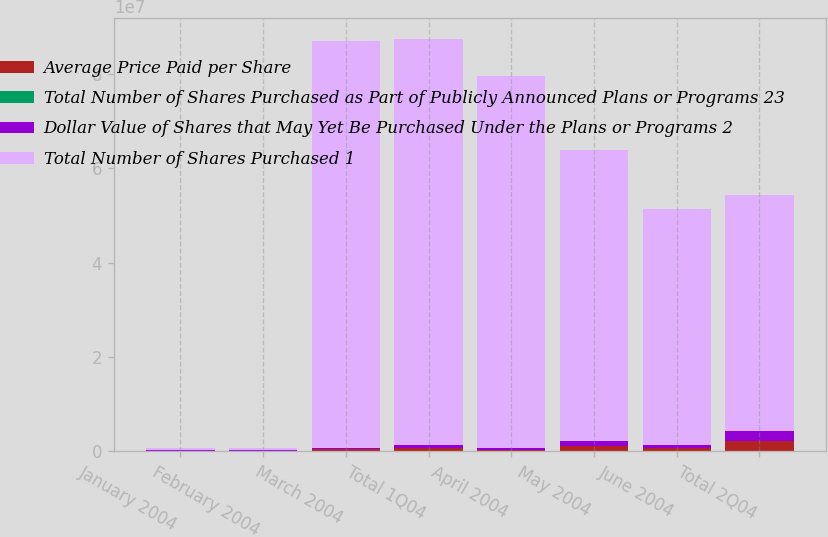Convert chart to OTSL. <chart><loc_0><loc_0><loc_500><loc_500><stacked_bar_chart><ecel><fcel>January 2004<fcel>February 2004<fcel>March 2004<fcel>Total 1Q04<fcel>April 2004<fcel>May 2004<fcel>June 2004<fcel>Total 2Q04<nl><fcel>Average Price Paid per Share<fcel>150000<fcel>129000<fcel>407000<fcel>686000<fcel>400000<fcel>1.05e+06<fcel>717500<fcel>2.1675e+06<nl><fcel>Total Number of Shares Purchased as Part of Publicly Announced Plans or Programs 23<fcel>20.71<fcel>21.25<fcel>19.9<fcel>20.33<fcel>18.16<fcel>16.23<fcel>16.38<fcel>16.64<nl><fcel>Dollar Value of Shares that May Yet Be Purchased Under the Plans or Programs 2<fcel>150000<fcel>129000<fcel>407000<fcel>686000<fcel>400000<fcel>1.05e+06<fcel>717500<fcel>2.1675e+06<nl><fcel>Total Number of Shares Purchased 1<fcel>407000<fcel>407000<fcel>8.60515e+07<fcel>8.60515e+07<fcel>7.87877e+07<fcel>6.17421e+07<fcel>4.99879e+07<fcel>4.99879e+07<nl></chart> 